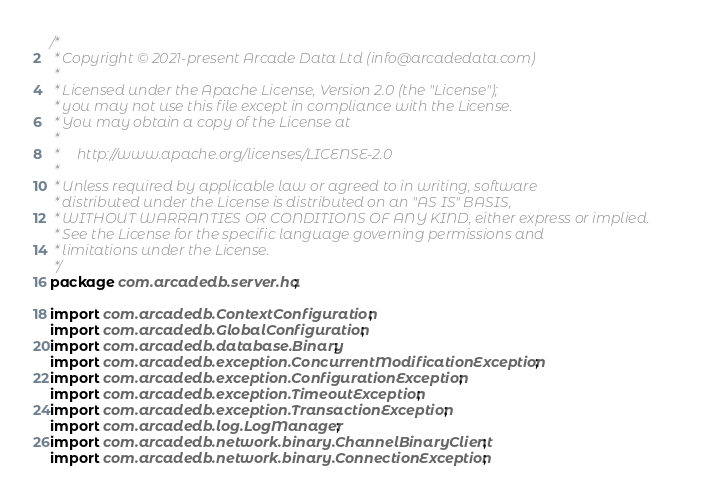<code> <loc_0><loc_0><loc_500><loc_500><_Java_>/*
 * Copyright © 2021-present Arcade Data Ltd (info@arcadedata.com)
 *
 * Licensed under the Apache License, Version 2.0 (the "License");
 * you may not use this file except in compliance with the License.
 * You may obtain a copy of the License at
 *
 *     http://www.apache.org/licenses/LICENSE-2.0
 *
 * Unless required by applicable law or agreed to in writing, software
 * distributed under the License is distributed on an "AS IS" BASIS,
 * WITHOUT WARRANTIES OR CONDITIONS OF ANY KIND, either express or implied.
 * See the License for the specific language governing permissions and
 * limitations under the License.
 */
package com.arcadedb.server.ha;

import com.arcadedb.ContextConfiguration;
import com.arcadedb.GlobalConfiguration;
import com.arcadedb.database.Binary;
import com.arcadedb.exception.ConcurrentModificationException;
import com.arcadedb.exception.ConfigurationException;
import com.arcadedb.exception.TimeoutException;
import com.arcadedb.exception.TransactionException;
import com.arcadedb.log.LogManager;
import com.arcadedb.network.binary.ChannelBinaryClient;
import com.arcadedb.network.binary.ConnectionException;</code> 